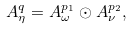<formula> <loc_0><loc_0><loc_500><loc_500>A _ { \eta } ^ { q } = A _ { \omega } ^ { p _ { 1 } } \odot A _ { \nu } ^ { p _ { 2 } } ,</formula> 